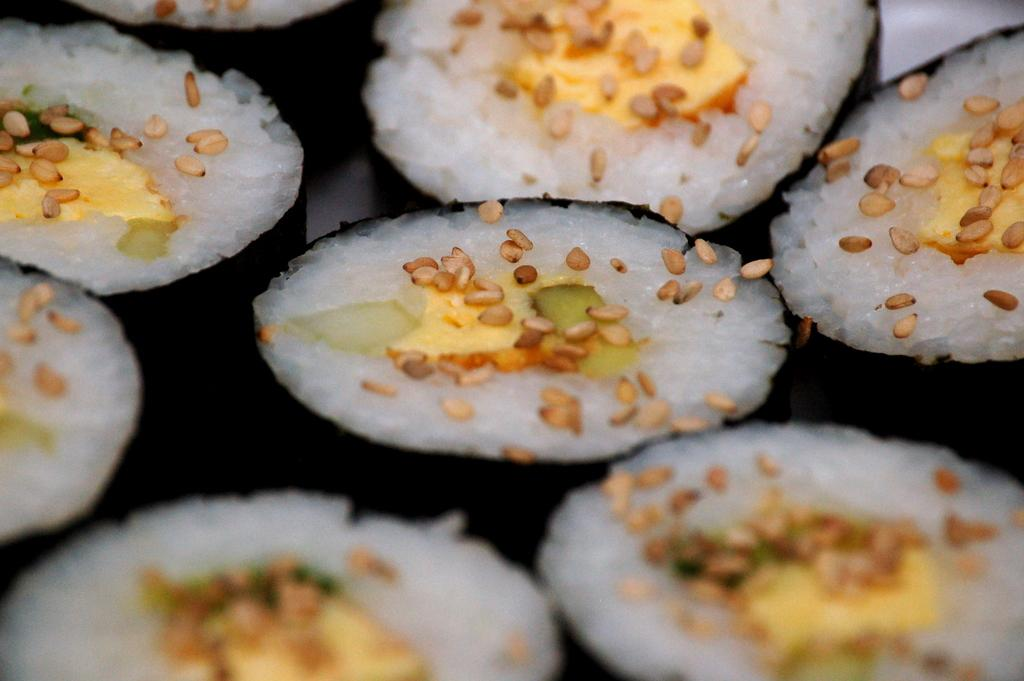What is present in the image? There is food in the image. What way does the lettuce contribute to the invention in the image? There is no lettuce or invention present in the image, so this question cannot be answered. 